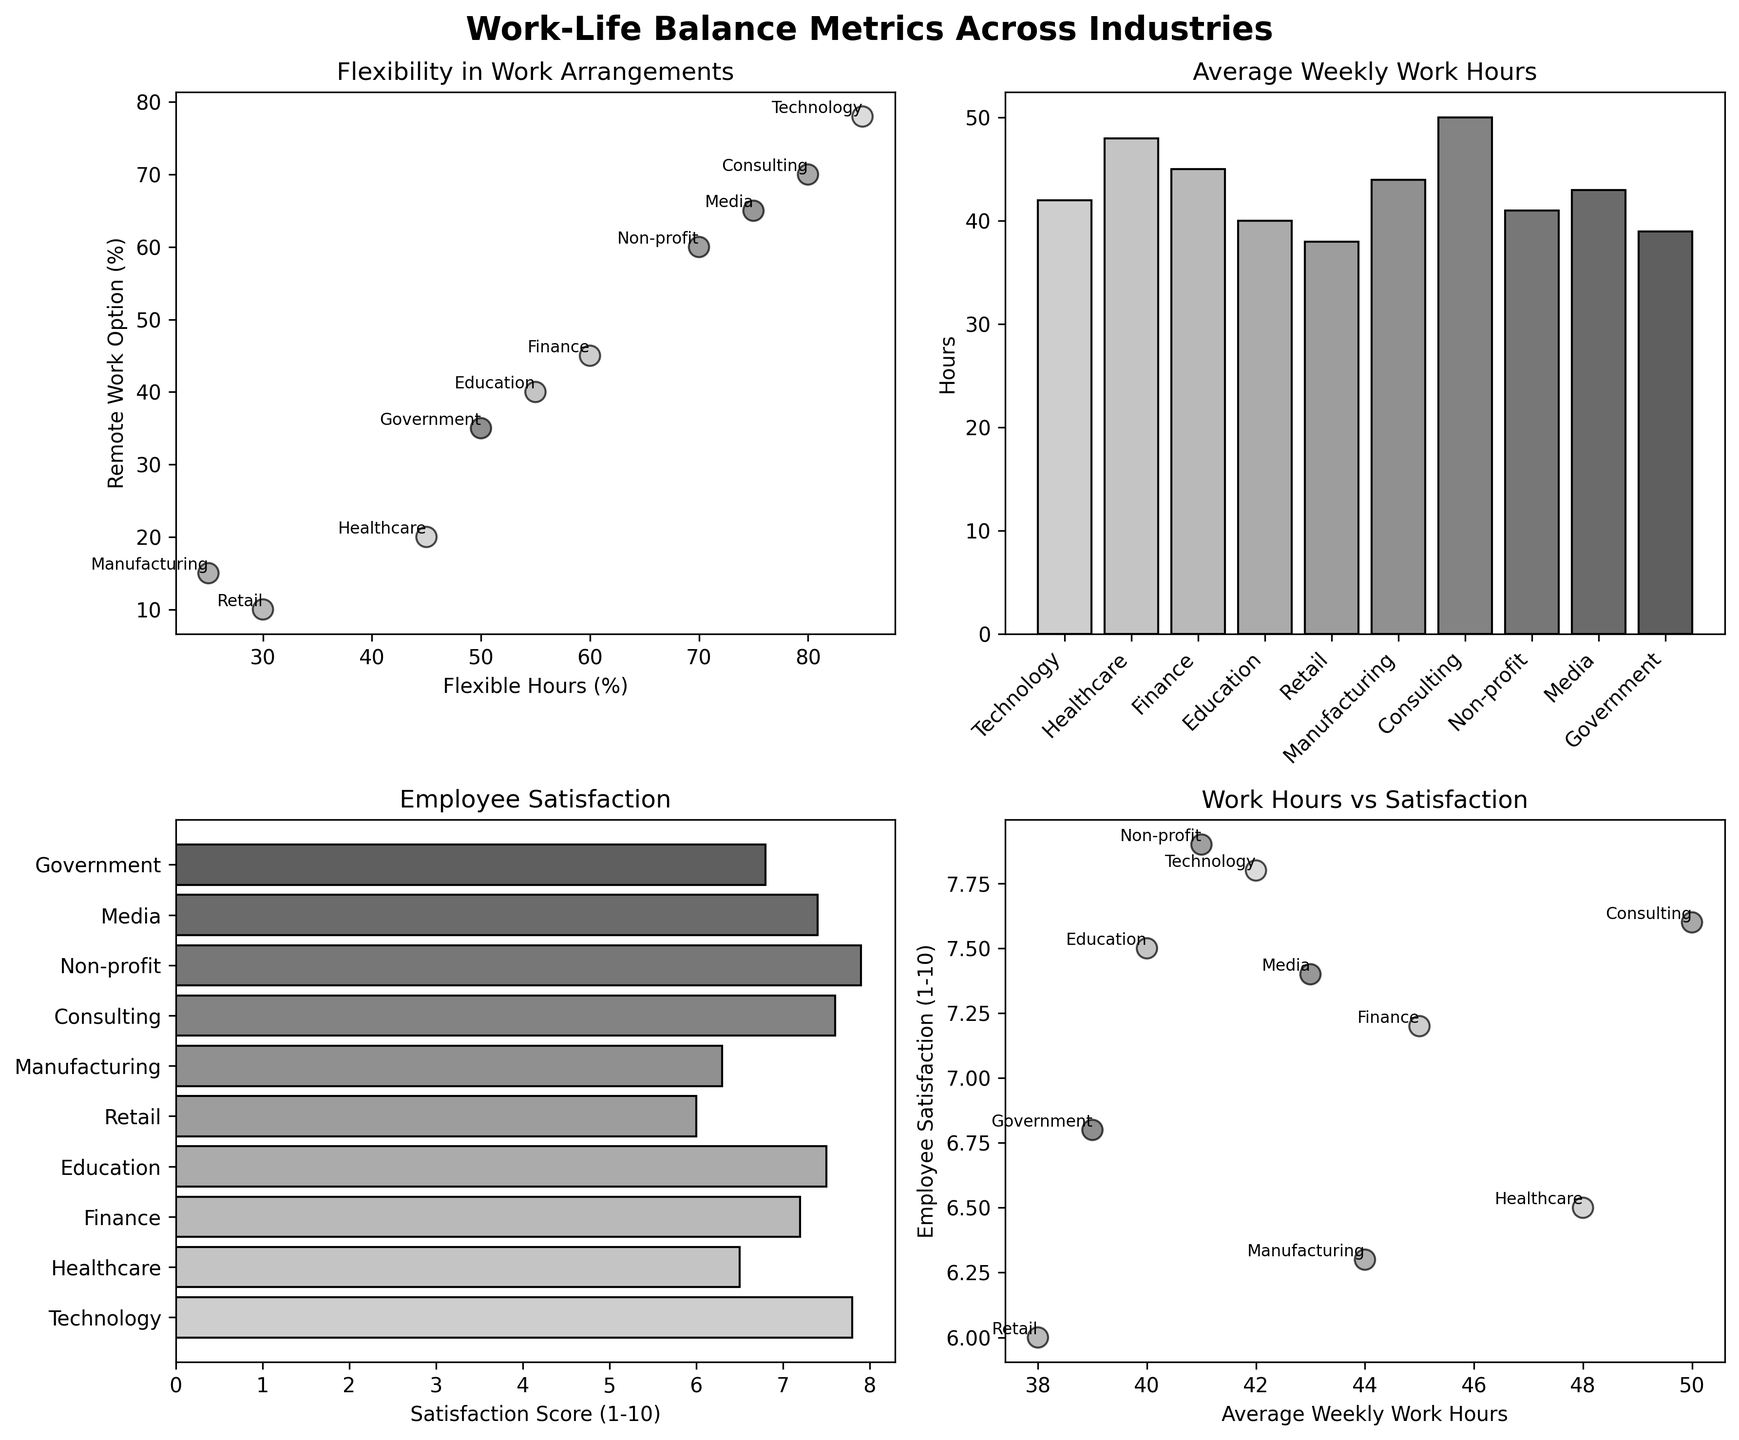What industry offers the highest percentage of flexible hours? Look at the scatter plot in the top left corner. Among the dots, the one with the highest value on the x-axis (Flexible Hours %) represents the Technology industry with 85%.
Answer: Technology Which industry has the lowest employee satisfaction score? Refer to the horizontal bar chart in the bottom left corner. Among the bars, the one with the shortest length belongs to Retail with a score of 6.0.
Answer: Retail How do consulting and media industries compare in terms of employee satisfaction? Check the horizontal bar chart in the bottom left corner. Consulting has a satisfaction score of 7.6, while Media has 7.4. Hence, Consulting scores slightly higher than Media.
Answer: Consulting is higher What is the relationship between average weekly work hours and employee satisfaction in the Technology industry? Refer to the scatter plot in the bottom right corner. Locate the Technology data point, which is (42, 7.8). It indicates that with 42 work hours per week, the satisfaction score is 7.8.
Answer: 42 hours, 7.8 satisfaction Which industries have both flexible hours and remote work as part of their work arrangements (over 50%)? Check the scatter plot in the top left corner. Identify points where both x and y values are above 50. These are Technology, Consulting, Non-profit, and Media.
Answer: Technology, Consulting, Non-profit, Media What is the average weekly work hours in the healthcare industry? Refer to the vertical bar chart in the top right corner. The value for Healthcare is given directly as 48 hours.
Answer: 48 hours How does employee satisfaction correlate with average weekly work hours across all industries? Look at the scatter plot in the bottom right corner. Generally, higher work hours tend to slightly correspond to lower satisfaction, though some high-flexibility industries have higher satisfaction.
Answer: Slight inverse relationship What industry has the most balanced score of high flexible hours and remote work options? Refer to the top left scatter plot. The points closest to the top right corner (high values of both flexible hours and remote work) indicate Technology.
Answer: Technology Which industry has the greatest difference between flexible hours and remote work options? Check the top left scatter plot. The Healthcare industry has a significant gap between 45% flexible hours and 20% remote work options.
Answer: Healthcare Compare average weekly work hours and satisfaction for Retail and Education industries. Look at the relevant bars in the vertical bar chart for weekly hours and horizontal bar chart for satisfaction. Retail has 38 hours and satisfaction 6.0, while Education has 40 hours and satisfaction 7.5.
Answer: Retail: 38 hrs/6.0, Education: 40 hrs/7.5 